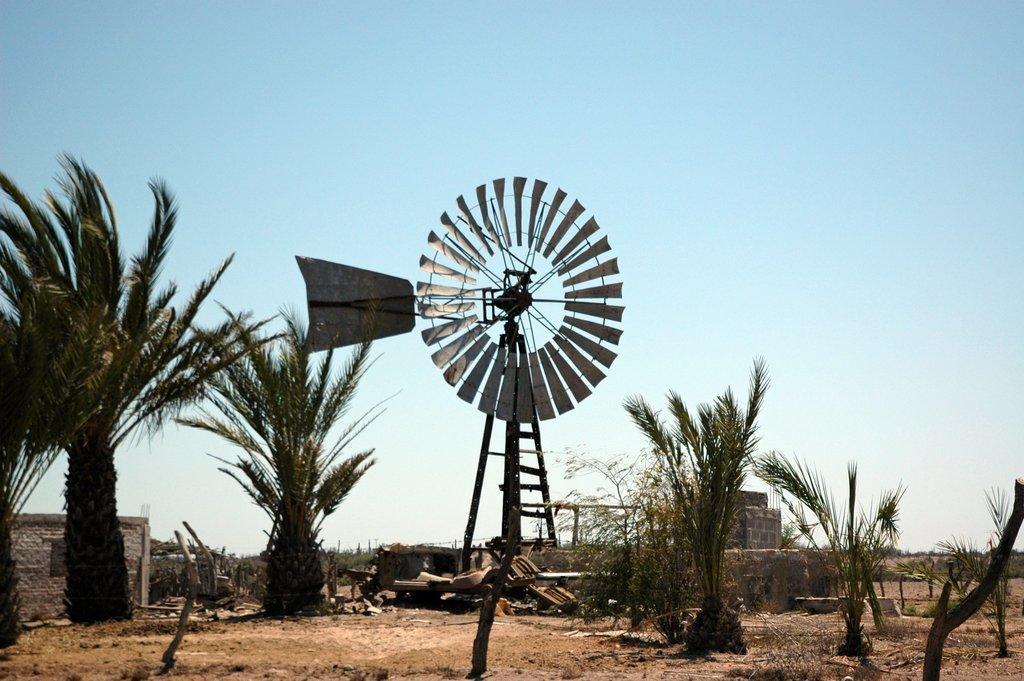In one or two sentences, can you explain what this image depicts? Sky is in blue color. Here we can see trees and windmill. 